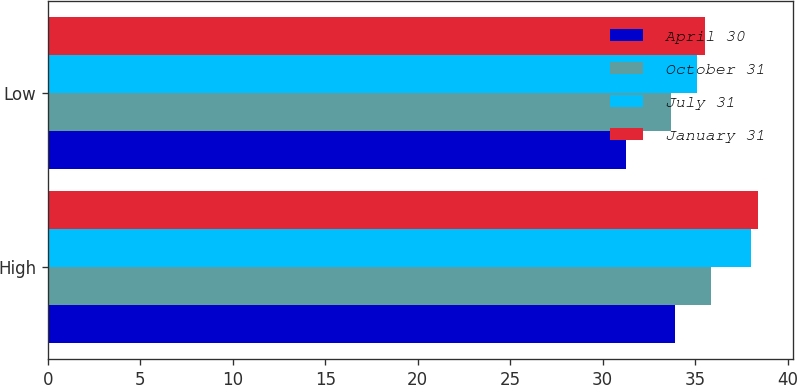Convert chart to OTSL. <chart><loc_0><loc_0><loc_500><loc_500><stacked_bar_chart><ecel><fcel>High<fcel>Low<nl><fcel>April 30<fcel>33.92<fcel>31.27<nl><fcel>October 31<fcel>35.88<fcel>33.72<nl><fcel>July 31<fcel>38.03<fcel>35.12<nl><fcel>January 31<fcel>38.4<fcel>35.52<nl></chart> 